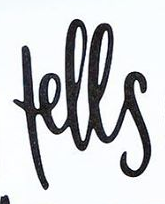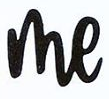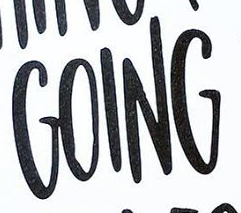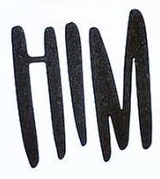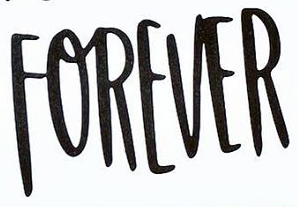Identify the words shown in these images in order, separated by a semicolon. fells; me; GOING; HIM; FOREVER 